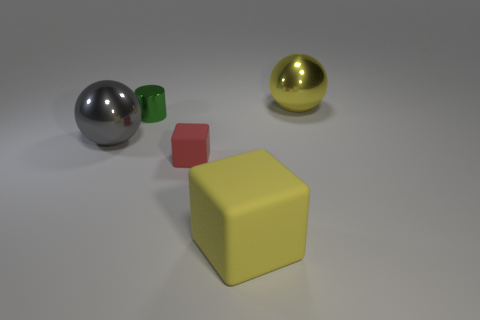Is there any other thing that has the same shape as the green metal object?
Give a very brief answer. No. There is another big shiny thing that is the same shape as the big yellow metal thing; what color is it?
Keep it short and to the point. Gray. Is the shape of the big yellow matte thing the same as the red rubber thing?
Ensure brevity in your answer.  Yes. How many cubes are either green objects or large blue things?
Your answer should be very brief. 0. What color is the other large object that is made of the same material as the red thing?
Give a very brief answer. Yellow. Is the size of the yellow thing that is behind the green cylinder the same as the tiny red block?
Provide a short and direct response. No. Are the red block and the yellow thing in front of the yellow sphere made of the same material?
Keep it short and to the point. Yes. What color is the thing that is in front of the red rubber object?
Your answer should be compact. Yellow. Are there any yellow things that are on the left side of the large shiny thing that is to the right of the tiny red thing?
Offer a terse response. Yes. Do the matte object that is behind the yellow matte block and the large sphere that is to the left of the tiny matte cube have the same color?
Provide a succinct answer. No. 